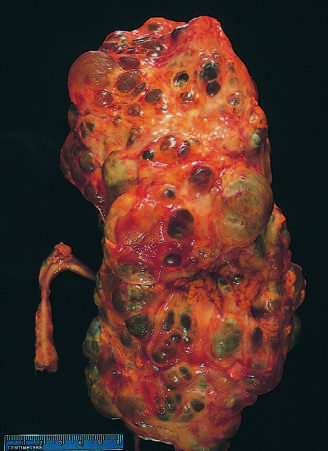s the kidney markedly enlarged?
Answer the question using a single word or phrase. Yes 